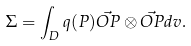Convert formula to latex. <formula><loc_0><loc_0><loc_500><loc_500>\Sigma = \int _ { D } q ( P ) \vec { O P } \otimes \vec { O P } d v .</formula> 